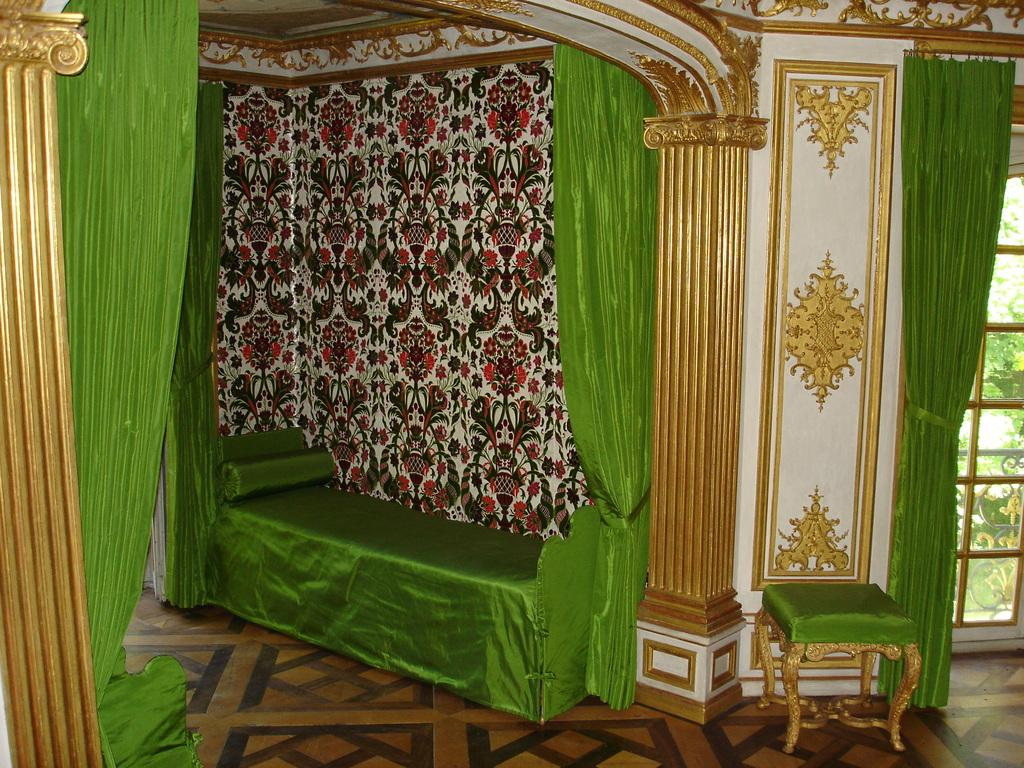What type of furniture is present in the image? There is a sofa and a chair in the image. What is placed on the sofa in the image? There is a pillow on the sofa in the image. What can be seen on the walls in the image? There are curtains in the image. What is visible on the floor in the image? The floor is visible in the image. What is in the background of the image? There is a wall in the background of the image. What type of bell can be heard ringing in the image? There is no bell present in the image, and therefore no sound can be heard. 